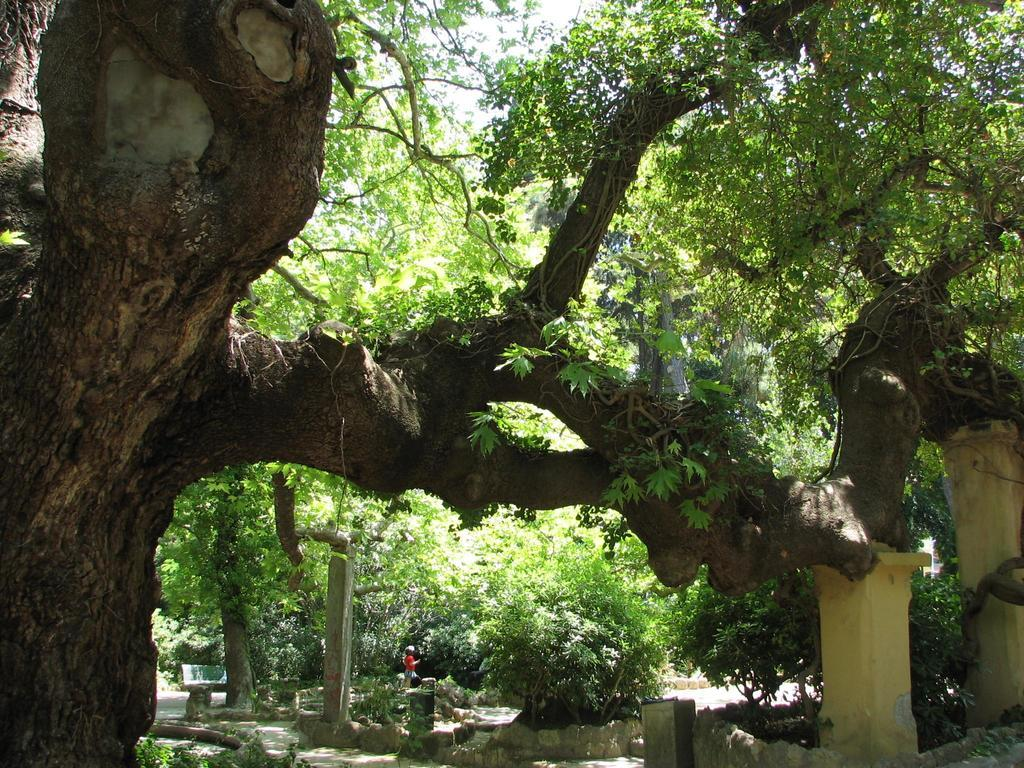What is the main feature of the image? There is a tree with a huge branch in the image. What else can be seen in the image? There are plants on a path and a person standing near the plants. Can you describe the person's appearance? The person is wearing a red dress. What type of appliance can be seen in the image? There is no appliance present in the image. Is there a playground visible in the image? There is no playground visible in the image. 